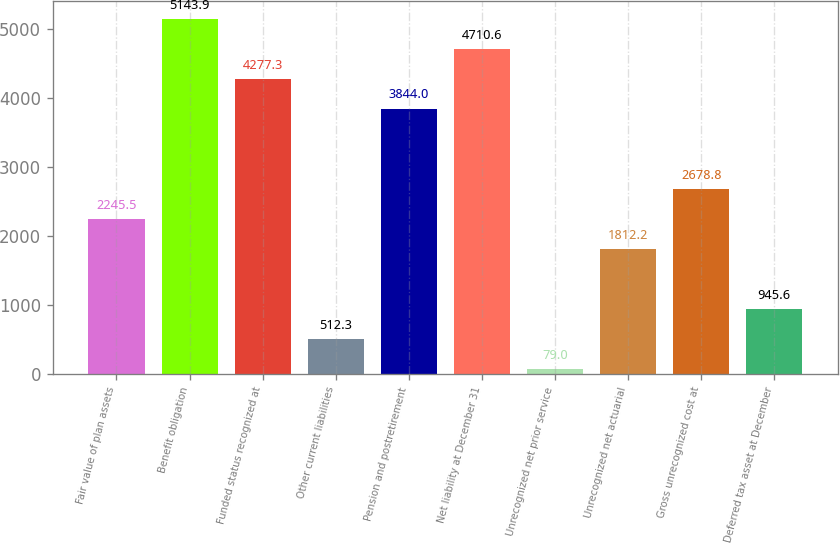<chart> <loc_0><loc_0><loc_500><loc_500><bar_chart><fcel>Fair value of plan assets<fcel>Benefit obligation<fcel>Funded status recognized at<fcel>Other current liabilities<fcel>Pension and postretirement<fcel>Net liability at December 31<fcel>Unrecognized net prior service<fcel>Unrecognized net actuarial<fcel>Gross unrecognized cost at<fcel>Deferred tax asset at December<nl><fcel>2245.5<fcel>5143.9<fcel>4277.3<fcel>512.3<fcel>3844<fcel>4710.6<fcel>79<fcel>1812.2<fcel>2678.8<fcel>945.6<nl></chart> 